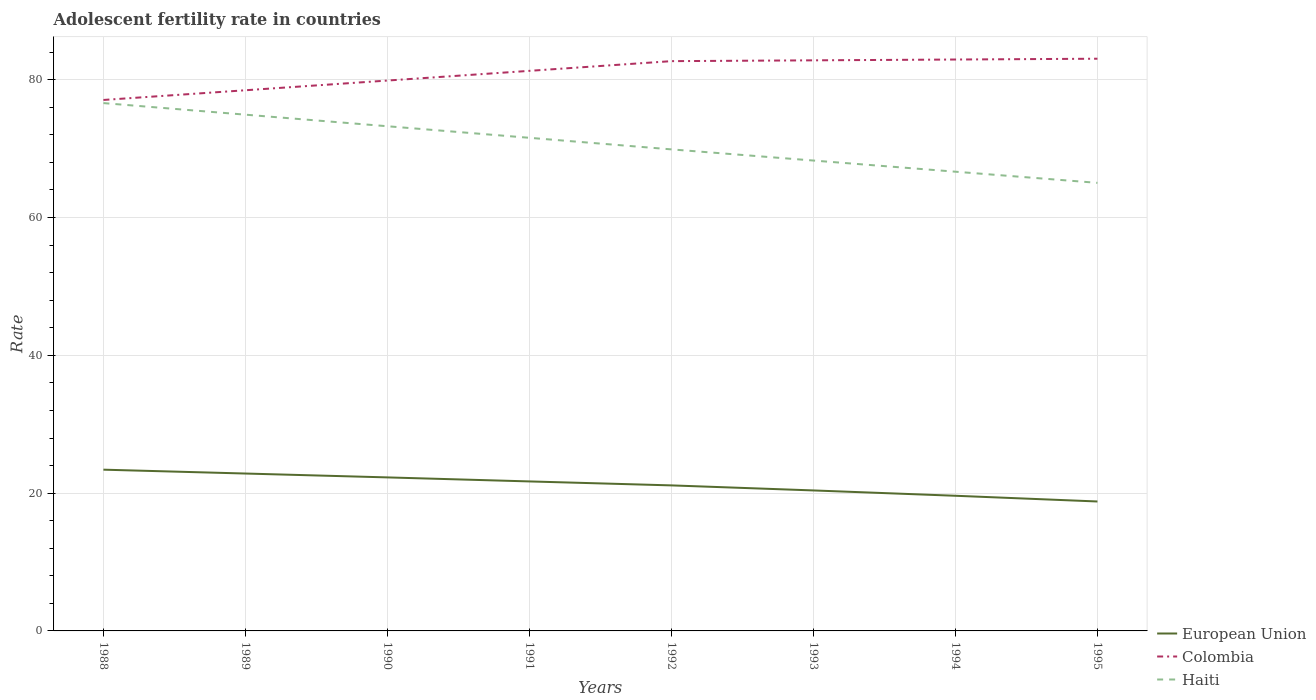How many different coloured lines are there?
Offer a very short reply. 3. Does the line corresponding to European Union intersect with the line corresponding to Haiti?
Keep it short and to the point. No. Is the number of lines equal to the number of legend labels?
Your answer should be compact. Yes. Across all years, what is the maximum adolescent fertility rate in European Union?
Your response must be concise. 18.79. In which year was the adolescent fertility rate in Haiti maximum?
Your response must be concise. 1995. What is the total adolescent fertility rate in European Union in the graph?
Make the answer very short. 3.02. What is the difference between the highest and the second highest adolescent fertility rate in European Union?
Provide a succinct answer. 4.62. How many lines are there?
Ensure brevity in your answer.  3. How many years are there in the graph?
Keep it short and to the point. 8. Are the values on the major ticks of Y-axis written in scientific E-notation?
Ensure brevity in your answer.  No. Does the graph contain any zero values?
Provide a succinct answer. No. Where does the legend appear in the graph?
Your answer should be very brief. Bottom right. How are the legend labels stacked?
Offer a very short reply. Vertical. What is the title of the graph?
Ensure brevity in your answer.  Adolescent fertility rate in countries. Does "Guam" appear as one of the legend labels in the graph?
Provide a succinct answer. No. What is the label or title of the Y-axis?
Your answer should be very brief. Rate. What is the Rate of European Union in 1988?
Your answer should be compact. 23.41. What is the Rate in Colombia in 1988?
Offer a terse response. 77.07. What is the Rate in Haiti in 1988?
Offer a terse response. 76.61. What is the Rate of European Union in 1989?
Keep it short and to the point. 22.84. What is the Rate in Colombia in 1989?
Ensure brevity in your answer.  78.48. What is the Rate in Haiti in 1989?
Provide a succinct answer. 74.93. What is the Rate of European Union in 1990?
Keep it short and to the point. 22.28. What is the Rate of Colombia in 1990?
Offer a terse response. 79.88. What is the Rate in Haiti in 1990?
Provide a succinct answer. 73.25. What is the Rate of European Union in 1991?
Your answer should be compact. 21.7. What is the Rate in Colombia in 1991?
Provide a short and direct response. 81.29. What is the Rate of Haiti in 1991?
Offer a very short reply. 71.57. What is the Rate of European Union in 1992?
Ensure brevity in your answer.  21.12. What is the Rate in Colombia in 1992?
Keep it short and to the point. 82.7. What is the Rate of Haiti in 1992?
Provide a short and direct response. 69.89. What is the Rate of European Union in 1993?
Provide a short and direct response. 20.39. What is the Rate in Colombia in 1993?
Your response must be concise. 82.82. What is the Rate in Haiti in 1993?
Your answer should be very brief. 68.27. What is the Rate of European Union in 1994?
Your answer should be very brief. 19.62. What is the Rate in Colombia in 1994?
Your answer should be compact. 82.94. What is the Rate of Haiti in 1994?
Your answer should be compact. 66.65. What is the Rate of European Union in 1995?
Offer a very short reply. 18.79. What is the Rate in Colombia in 1995?
Your response must be concise. 83.05. What is the Rate of Haiti in 1995?
Provide a short and direct response. 65.04. Across all years, what is the maximum Rate in European Union?
Provide a short and direct response. 23.41. Across all years, what is the maximum Rate in Colombia?
Provide a succinct answer. 83.05. Across all years, what is the maximum Rate in Haiti?
Ensure brevity in your answer.  76.61. Across all years, what is the minimum Rate in European Union?
Provide a short and direct response. 18.79. Across all years, what is the minimum Rate of Colombia?
Ensure brevity in your answer.  77.07. Across all years, what is the minimum Rate in Haiti?
Your answer should be compact. 65.04. What is the total Rate of European Union in the graph?
Your answer should be very brief. 170.15. What is the total Rate of Colombia in the graph?
Provide a succinct answer. 648.23. What is the total Rate of Haiti in the graph?
Offer a very short reply. 566.23. What is the difference between the Rate of European Union in 1988 and that in 1989?
Provide a short and direct response. 0.56. What is the difference between the Rate in Colombia in 1988 and that in 1989?
Provide a succinct answer. -1.41. What is the difference between the Rate in Haiti in 1988 and that in 1989?
Keep it short and to the point. 1.68. What is the difference between the Rate in European Union in 1988 and that in 1990?
Your answer should be very brief. 1.12. What is the difference between the Rate in Colombia in 1988 and that in 1990?
Your answer should be very brief. -2.82. What is the difference between the Rate of Haiti in 1988 and that in 1990?
Ensure brevity in your answer.  3.36. What is the difference between the Rate of European Union in 1988 and that in 1991?
Provide a succinct answer. 1.71. What is the difference between the Rate in Colombia in 1988 and that in 1991?
Your answer should be compact. -4.23. What is the difference between the Rate in Haiti in 1988 and that in 1991?
Provide a short and direct response. 5.04. What is the difference between the Rate in European Union in 1988 and that in 1992?
Give a very brief answer. 2.28. What is the difference between the Rate of Colombia in 1988 and that in 1992?
Your answer should be very brief. -5.63. What is the difference between the Rate in Haiti in 1988 and that in 1992?
Your answer should be compact. 6.72. What is the difference between the Rate of European Union in 1988 and that in 1993?
Your response must be concise. 3.02. What is the difference between the Rate of Colombia in 1988 and that in 1993?
Your answer should be very brief. -5.75. What is the difference between the Rate in Haiti in 1988 and that in 1993?
Give a very brief answer. 8.34. What is the difference between the Rate of European Union in 1988 and that in 1994?
Your response must be concise. 3.79. What is the difference between the Rate of Colombia in 1988 and that in 1994?
Your answer should be very brief. -5.87. What is the difference between the Rate of Haiti in 1988 and that in 1994?
Offer a very short reply. 9.96. What is the difference between the Rate of European Union in 1988 and that in 1995?
Your answer should be very brief. 4.62. What is the difference between the Rate in Colombia in 1988 and that in 1995?
Offer a very short reply. -5.99. What is the difference between the Rate of Haiti in 1988 and that in 1995?
Offer a terse response. 11.58. What is the difference between the Rate in European Union in 1989 and that in 1990?
Offer a terse response. 0.56. What is the difference between the Rate of Colombia in 1989 and that in 1990?
Keep it short and to the point. -1.41. What is the difference between the Rate of Haiti in 1989 and that in 1990?
Provide a succinct answer. 1.68. What is the difference between the Rate of European Union in 1989 and that in 1991?
Give a very brief answer. 1.15. What is the difference between the Rate of Colombia in 1989 and that in 1991?
Offer a very short reply. -2.82. What is the difference between the Rate in Haiti in 1989 and that in 1991?
Keep it short and to the point. 3.36. What is the difference between the Rate of European Union in 1989 and that in 1992?
Make the answer very short. 1.72. What is the difference between the Rate of Colombia in 1989 and that in 1992?
Keep it short and to the point. -4.23. What is the difference between the Rate in Haiti in 1989 and that in 1992?
Offer a terse response. 5.04. What is the difference between the Rate in European Union in 1989 and that in 1993?
Give a very brief answer. 2.45. What is the difference between the Rate of Colombia in 1989 and that in 1993?
Provide a succinct answer. -4.34. What is the difference between the Rate of Haiti in 1989 and that in 1993?
Your answer should be very brief. 6.66. What is the difference between the Rate of European Union in 1989 and that in 1994?
Your response must be concise. 3.23. What is the difference between the Rate of Colombia in 1989 and that in 1994?
Your answer should be compact. -4.46. What is the difference between the Rate in Haiti in 1989 and that in 1994?
Give a very brief answer. 8.28. What is the difference between the Rate of European Union in 1989 and that in 1995?
Offer a terse response. 4.06. What is the difference between the Rate in Colombia in 1989 and that in 1995?
Ensure brevity in your answer.  -4.58. What is the difference between the Rate in Haiti in 1989 and that in 1995?
Your response must be concise. 9.9. What is the difference between the Rate of European Union in 1990 and that in 1991?
Keep it short and to the point. 0.58. What is the difference between the Rate in Colombia in 1990 and that in 1991?
Your response must be concise. -1.41. What is the difference between the Rate of Haiti in 1990 and that in 1991?
Your answer should be very brief. 1.68. What is the difference between the Rate of European Union in 1990 and that in 1992?
Make the answer very short. 1.16. What is the difference between the Rate of Colombia in 1990 and that in 1992?
Keep it short and to the point. -2.82. What is the difference between the Rate of Haiti in 1990 and that in 1992?
Offer a terse response. 3.36. What is the difference between the Rate in European Union in 1990 and that in 1993?
Offer a very short reply. 1.89. What is the difference between the Rate of Colombia in 1990 and that in 1993?
Your response must be concise. -2.93. What is the difference between the Rate of Haiti in 1990 and that in 1993?
Provide a short and direct response. 4.98. What is the difference between the Rate of European Union in 1990 and that in 1994?
Ensure brevity in your answer.  2.67. What is the difference between the Rate in Colombia in 1990 and that in 1994?
Give a very brief answer. -3.05. What is the difference between the Rate in Haiti in 1990 and that in 1994?
Your response must be concise. 6.6. What is the difference between the Rate of European Union in 1990 and that in 1995?
Offer a very short reply. 3.5. What is the difference between the Rate in Colombia in 1990 and that in 1995?
Offer a terse response. -3.17. What is the difference between the Rate in Haiti in 1990 and that in 1995?
Your answer should be very brief. 8.22. What is the difference between the Rate in European Union in 1991 and that in 1992?
Provide a short and direct response. 0.58. What is the difference between the Rate of Colombia in 1991 and that in 1992?
Your answer should be very brief. -1.41. What is the difference between the Rate in Haiti in 1991 and that in 1992?
Your response must be concise. 1.68. What is the difference between the Rate of European Union in 1991 and that in 1993?
Keep it short and to the point. 1.31. What is the difference between the Rate of Colombia in 1991 and that in 1993?
Offer a terse response. -1.53. What is the difference between the Rate in Haiti in 1991 and that in 1993?
Keep it short and to the point. 3.3. What is the difference between the Rate in European Union in 1991 and that in 1994?
Your answer should be very brief. 2.08. What is the difference between the Rate of Colombia in 1991 and that in 1994?
Your answer should be very brief. -1.64. What is the difference between the Rate of Haiti in 1991 and that in 1994?
Ensure brevity in your answer.  4.92. What is the difference between the Rate in European Union in 1991 and that in 1995?
Make the answer very short. 2.91. What is the difference between the Rate in Colombia in 1991 and that in 1995?
Provide a succinct answer. -1.76. What is the difference between the Rate in Haiti in 1991 and that in 1995?
Keep it short and to the point. 6.54. What is the difference between the Rate in European Union in 1992 and that in 1993?
Your answer should be compact. 0.73. What is the difference between the Rate of Colombia in 1992 and that in 1993?
Keep it short and to the point. -0.12. What is the difference between the Rate of Haiti in 1992 and that in 1993?
Your answer should be compact. 1.62. What is the difference between the Rate of European Union in 1992 and that in 1994?
Provide a short and direct response. 1.51. What is the difference between the Rate of Colombia in 1992 and that in 1994?
Provide a short and direct response. -0.23. What is the difference between the Rate in Haiti in 1992 and that in 1994?
Offer a very short reply. 3.24. What is the difference between the Rate in European Union in 1992 and that in 1995?
Give a very brief answer. 2.34. What is the difference between the Rate of Colombia in 1992 and that in 1995?
Offer a very short reply. -0.35. What is the difference between the Rate of Haiti in 1992 and that in 1995?
Provide a short and direct response. 4.86. What is the difference between the Rate of European Union in 1993 and that in 1994?
Your answer should be very brief. 0.77. What is the difference between the Rate in Colombia in 1993 and that in 1994?
Give a very brief answer. -0.12. What is the difference between the Rate in Haiti in 1993 and that in 1994?
Your answer should be compact. 1.62. What is the difference between the Rate in European Union in 1993 and that in 1995?
Your answer should be very brief. 1.6. What is the difference between the Rate in Colombia in 1993 and that in 1995?
Ensure brevity in your answer.  -0.23. What is the difference between the Rate in Haiti in 1993 and that in 1995?
Ensure brevity in your answer.  3.24. What is the difference between the Rate of European Union in 1994 and that in 1995?
Ensure brevity in your answer.  0.83. What is the difference between the Rate of Colombia in 1994 and that in 1995?
Ensure brevity in your answer.  -0.12. What is the difference between the Rate of Haiti in 1994 and that in 1995?
Give a very brief answer. 1.62. What is the difference between the Rate of European Union in 1988 and the Rate of Colombia in 1989?
Make the answer very short. -55.07. What is the difference between the Rate of European Union in 1988 and the Rate of Haiti in 1989?
Make the answer very short. -51.53. What is the difference between the Rate of Colombia in 1988 and the Rate of Haiti in 1989?
Keep it short and to the point. 2.13. What is the difference between the Rate of European Union in 1988 and the Rate of Colombia in 1990?
Provide a succinct answer. -56.48. What is the difference between the Rate in European Union in 1988 and the Rate in Haiti in 1990?
Make the answer very short. -49.85. What is the difference between the Rate in Colombia in 1988 and the Rate in Haiti in 1990?
Your answer should be very brief. 3.81. What is the difference between the Rate in European Union in 1988 and the Rate in Colombia in 1991?
Offer a terse response. -57.89. What is the difference between the Rate of European Union in 1988 and the Rate of Haiti in 1991?
Keep it short and to the point. -48.17. What is the difference between the Rate of Colombia in 1988 and the Rate of Haiti in 1991?
Ensure brevity in your answer.  5.49. What is the difference between the Rate of European Union in 1988 and the Rate of Colombia in 1992?
Offer a very short reply. -59.3. What is the difference between the Rate in European Union in 1988 and the Rate in Haiti in 1992?
Your response must be concise. -46.49. What is the difference between the Rate in Colombia in 1988 and the Rate in Haiti in 1992?
Provide a succinct answer. 7.17. What is the difference between the Rate in European Union in 1988 and the Rate in Colombia in 1993?
Ensure brevity in your answer.  -59.41. What is the difference between the Rate of European Union in 1988 and the Rate of Haiti in 1993?
Ensure brevity in your answer.  -44.87. What is the difference between the Rate in Colombia in 1988 and the Rate in Haiti in 1993?
Give a very brief answer. 8.79. What is the difference between the Rate of European Union in 1988 and the Rate of Colombia in 1994?
Your answer should be compact. -59.53. What is the difference between the Rate of European Union in 1988 and the Rate of Haiti in 1994?
Your answer should be very brief. -43.25. What is the difference between the Rate of Colombia in 1988 and the Rate of Haiti in 1994?
Provide a succinct answer. 10.41. What is the difference between the Rate in European Union in 1988 and the Rate in Colombia in 1995?
Offer a very short reply. -59.65. What is the difference between the Rate of European Union in 1988 and the Rate of Haiti in 1995?
Make the answer very short. -41.63. What is the difference between the Rate in Colombia in 1988 and the Rate in Haiti in 1995?
Your response must be concise. 12.03. What is the difference between the Rate in European Union in 1989 and the Rate in Colombia in 1990?
Your answer should be very brief. -57.04. What is the difference between the Rate of European Union in 1989 and the Rate of Haiti in 1990?
Make the answer very short. -50.41. What is the difference between the Rate of Colombia in 1989 and the Rate of Haiti in 1990?
Keep it short and to the point. 5.22. What is the difference between the Rate in European Union in 1989 and the Rate in Colombia in 1991?
Provide a short and direct response. -58.45. What is the difference between the Rate in European Union in 1989 and the Rate in Haiti in 1991?
Give a very brief answer. -48.73. What is the difference between the Rate in Colombia in 1989 and the Rate in Haiti in 1991?
Provide a short and direct response. 6.9. What is the difference between the Rate in European Union in 1989 and the Rate in Colombia in 1992?
Ensure brevity in your answer.  -59.86. What is the difference between the Rate of European Union in 1989 and the Rate of Haiti in 1992?
Provide a short and direct response. -47.05. What is the difference between the Rate of Colombia in 1989 and the Rate of Haiti in 1992?
Ensure brevity in your answer.  8.58. What is the difference between the Rate of European Union in 1989 and the Rate of Colombia in 1993?
Give a very brief answer. -59.97. What is the difference between the Rate of European Union in 1989 and the Rate of Haiti in 1993?
Provide a succinct answer. -45.43. What is the difference between the Rate in Colombia in 1989 and the Rate in Haiti in 1993?
Offer a very short reply. 10.2. What is the difference between the Rate of European Union in 1989 and the Rate of Colombia in 1994?
Provide a short and direct response. -60.09. What is the difference between the Rate of European Union in 1989 and the Rate of Haiti in 1994?
Give a very brief answer. -43.81. What is the difference between the Rate in Colombia in 1989 and the Rate in Haiti in 1994?
Provide a short and direct response. 11.82. What is the difference between the Rate in European Union in 1989 and the Rate in Colombia in 1995?
Keep it short and to the point. -60.21. What is the difference between the Rate of European Union in 1989 and the Rate of Haiti in 1995?
Ensure brevity in your answer.  -42.19. What is the difference between the Rate of Colombia in 1989 and the Rate of Haiti in 1995?
Give a very brief answer. 13.44. What is the difference between the Rate of European Union in 1990 and the Rate of Colombia in 1991?
Offer a very short reply. -59.01. What is the difference between the Rate in European Union in 1990 and the Rate in Haiti in 1991?
Your answer should be very brief. -49.29. What is the difference between the Rate of Colombia in 1990 and the Rate of Haiti in 1991?
Offer a very short reply. 8.31. What is the difference between the Rate in European Union in 1990 and the Rate in Colombia in 1992?
Your answer should be very brief. -60.42. What is the difference between the Rate in European Union in 1990 and the Rate in Haiti in 1992?
Make the answer very short. -47.61. What is the difference between the Rate in Colombia in 1990 and the Rate in Haiti in 1992?
Offer a terse response. 9.99. What is the difference between the Rate of European Union in 1990 and the Rate of Colombia in 1993?
Ensure brevity in your answer.  -60.54. What is the difference between the Rate in European Union in 1990 and the Rate in Haiti in 1993?
Provide a short and direct response. -45.99. What is the difference between the Rate in Colombia in 1990 and the Rate in Haiti in 1993?
Offer a very short reply. 11.61. What is the difference between the Rate in European Union in 1990 and the Rate in Colombia in 1994?
Your answer should be compact. -60.65. What is the difference between the Rate in European Union in 1990 and the Rate in Haiti in 1994?
Provide a succinct answer. -44.37. What is the difference between the Rate in Colombia in 1990 and the Rate in Haiti in 1994?
Offer a terse response. 13.23. What is the difference between the Rate in European Union in 1990 and the Rate in Colombia in 1995?
Offer a very short reply. -60.77. What is the difference between the Rate of European Union in 1990 and the Rate of Haiti in 1995?
Ensure brevity in your answer.  -42.75. What is the difference between the Rate of Colombia in 1990 and the Rate of Haiti in 1995?
Make the answer very short. 14.85. What is the difference between the Rate of European Union in 1991 and the Rate of Colombia in 1992?
Keep it short and to the point. -61. What is the difference between the Rate of European Union in 1991 and the Rate of Haiti in 1992?
Give a very brief answer. -48.2. What is the difference between the Rate of Colombia in 1991 and the Rate of Haiti in 1992?
Ensure brevity in your answer.  11.4. What is the difference between the Rate in European Union in 1991 and the Rate in Colombia in 1993?
Make the answer very short. -61.12. What is the difference between the Rate in European Union in 1991 and the Rate in Haiti in 1993?
Your answer should be compact. -46.58. What is the difference between the Rate of Colombia in 1991 and the Rate of Haiti in 1993?
Your answer should be very brief. 13.02. What is the difference between the Rate of European Union in 1991 and the Rate of Colombia in 1994?
Keep it short and to the point. -61.24. What is the difference between the Rate of European Union in 1991 and the Rate of Haiti in 1994?
Provide a succinct answer. -44.96. What is the difference between the Rate in Colombia in 1991 and the Rate in Haiti in 1994?
Your response must be concise. 14.64. What is the difference between the Rate in European Union in 1991 and the Rate in Colombia in 1995?
Your response must be concise. -61.36. What is the difference between the Rate of European Union in 1991 and the Rate of Haiti in 1995?
Make the answer very short. -43.34. What is the difference between the Rate of Colombia in 1991 and the Rate of Haiti in 1995?
Provide a short and direct response. 16.26. What is the difference between the Rate of European Union in 1992 and the Rate of Colombia in 1993?
Provide a short and direct response. -61.7. What is the difference between the Rate of European Union in 1992 and the Rate of Haiti in 1993?
Provide a succinct answer. -47.15. What is the difference between the Rate in Colombia in 1992 and the Rate in Haiti in 1993?
Your answer should be very brief. 14.43. What is the difference between the Rate in European Union in 1992 and the Rate in Colombia in 1994?
Your answer should be very brief. -61.81. What is the difference between the Rate of European Union in 1992 and the Rate of Haiti in 1994?
Offer a very short reply. -45.53. What is the difference between the Rate in Colombia in 1992 and the Rate in Haiti in 1994?
Ensure brevity in your answer.  16.05. What is the difference between the Rate of European Union in 1992 and the Rate of Colombia in 1995?
Offer a terse response. -61.93. What is the difference between the Rate in European Union in 1992 and the Rate in Haiti in 1995?
Provide a succinct answer. -43.91. What is the difference between the Rate of Colombia in 1992 and the Rate of Haiti in 1995?
Offer a terse response. 17.67. What is the difference between the Rate in European Union in 1993 and the Rate in Colombia in 1994?
Keep it short and to the point. -62.55. What is the difference between the Rate in European Union in 1993 and the Rate in Haiti in 1994?
Your answer should be very brief. -46.26. What is the difference between the Rate of Colombia in 1993 and the Rate of Haiti in 1994?
Offer a very short reply. 16.16. What is the difference between the Rate in European Union in 1993 and the Rate in Colombia in 1995?
Give a very brief answer. -62.66. What is the difference between the Rate in European Union in 1993 and the Rate in Haiti in 1995?
Provide a short and direct response. -44.64. What is the difference between the Rate of Colombia in 1993 and the Rate of Haiti in 1995?
Your response must be concise. 17.78. What is the difference between the Rate in European Union in 1994 and the Rate in Colombia in 1995?
Provide a succinct answer. -63.44. What is the difference between the Rate of European Union in 1994 and the Rate of Haiti in 1995?
Provide a short and direct response. -45.42. What is the difference between the Rate in Colombia in 1994 and the Rate in Haiti in 1995?
Provide a succinct answer. 17.9. What is the average Rate of European Union per year?
Your answer should be compact. 21.27. What is the average Rate in Colombia per year?
Your answer should be compact. 81.03. What is the average Rate of Haiti per year?
Provide a short and direct response. 70.78. In the year 1988, what is the difference between the Rate in European Union and Rate in Colombia?
Your answer should be compact. -53.66. In the year 1988, what is the difference between the Rate of European Union and Rate of Haiti?
Provide a succinct answer. -53.21. In the year 1988, what is the difference between the Rate in Colombia and Rate in Haiti?
Your answer should be compact. 0.46. In the year 1989, what is the difference between the Rate in European Union and Rate in Colombia?
Ensure brevity in your answer.  -55.63. In the year 1989, what is the difference between the Rate of European Union and Rate of Haiti?
Make the answer very short. -52.09. In the year 1989, what is the difference between the Rate in Colombia and Rate in Haiti?
Provide a succinct answer. 3.54. In the year 1990, what is the difference between the Rate of European Union and Rate of Colombia?
Offer a very short reply. -57.6. In the year 1990, what is the difference between the Rate of European Union and Rate of Haiti?
Your answer should be very brief. -50.97. In the year 1990, what is the difference between the Rate of Colombia and Rate of Haiti?
Your answer should be very brief. 6.63. In the year 1991, what is the difference between the Rate in European Union and Rate in Colombia?
Provide a short and direct response. -59.59. In the year 1991, what is the difference between the Rate in European Union and Rate in Haiti?
Make the answer very short. -49.87. In the year 1991, what is the difference between the Rate of Colombia and Rate of Haiti?
Your answer should be very brief. 9.72. In the year 1992, what is the difference between the Rate in European Union and Rate in Colombia?
Provide a succinct answer. -61.58. In the year 1992, what is the difference between the Rate in European Union and Rate in Haiti?
Offer a terse response. -48.77. In the year 1992, what is the difference between the Rate of Colombia and Rate of Haiti?
Your answer should be very brief. 12.81. In the year 1993, what is the difference between the Rate of European Union and Rate of Colombia?
Provide a short and direct response. -62.43. In the year 1993, what is the difference between the Rate of European Union and Rate of Haiti?
Give a very brief answer. -47.88. In the year 1993, what is the difference between the Rate of Colombia and Rate of Haiti?
Your response must be concise. 14.54. In the year 1994, what is the difference between the Rate of European Union and Rate of Colombia?
Make the answer very short. -63.32. In the year 1994, what is the difference between the Rate of European Union and Rate of Haiti?
Your answer should be very brief. -47.04. In the year 1994, what is the difference between the Rate in Colombia and Rate in Haiti?
Offer a terse response. 16.28. In the year 1995, what is the difference between the Rate in European Union and Rate in Colombia?
Make the answer very short. -64.27. In the year 1995, what is the difference between the Rate in European Union and Rate in Haiti?
Your answer should be very brief. -46.25. In the year 1995, what is the difference between the Rate in Colombia and Rate in Haiti?
Your response must be concise. 18.02. What is the ratio of the Rate in European Union in 1988 to that in 1989?
Keep it short and to the point. 1.02. What is the ratio of the Rate of Colombia in 1988 to that in 1989?
Ensure brevity in your answer.  0.98. What is the ratio of the Rate in Haiti in 1988 to that in 1989?
Offer a very short reply. 1.02. What is the ratio of the Rate of European Union in 1988 to that in 1990?
Provide a short and direct response. 1.05. What is the ratio of the Rate in Colombia in 1988 to that in 1990?
Your answer should be very brief. 0.96. What is the ratio of the Rate of Haiti in 1988 to that in 1990?
Your answer should be very brief. 1.05. What is the ratio of the Rate of European Union in 1988 to that in 1991?
Make the answer very short. 1.08. What is the ratio of the Rate in Colombia in 1988 to that in 1991?
Offer a very short reply. 0.95. What is the ratio of the Rate in Haiti in 1988 to that in 1991?
Offer a terse response. 1.07. What is the ratio of the Rate of European Union in 1988 to that in 1992?
Ensure brevity in your answer.  1.11. What is the ratio of the Rate in Colombia in 1988 to that in 1992?
Give a very brief answer. 0.93. What is the ratio of the Rate of Haiti in 1988 to that in 1992?
Keep it short and to the point. 1.1. What is the ratio of the Rate in European Union in 1988 to that in 1993?
Your response must be concise. 1.15. What is the ratio of the Rate of Colombia in 1988 to that in 1993?
Keep it short and to the point. 0.93. What is the ratio of the Rate of Haiti in 1988 to that in 1993?
Your answer should be compact. 1.12. What is the ratio of the Rate in European Union in 1988 to that in 1994?
Your answer should be compact. 1.19. What is the ratio of the Rate of Colombia in 1988 to that in 1994?
Your answer should be compact. 0.93. What is the ratio of the Rate in Haiti in 1988 to that in 1994?
Ensure brevity in your answer.  1.15. What is the ratio of the Rate in European Union in 1988 to that in 1995?
Ensure brevity in your answer.  1.25. What is the ratio of the Rate in Colombia in 1988 to that in 1995?
Your answer should be compact. 0.93. What is the ratio of the Rate of Haiti in 1988 to that in 1995?
Ensure brevity in your answer.  1.18. What is the ratio of the Rate of European Union in 1989 to that in 1990?
Keep it short and to the point. 1.03. What is the ratio of the Rate of Colombia in 1989 to that in 1990?
Ensure brevity in your answer.  0.98. What is the ratio of the Rate of Haiti in 1989 to that in 1990?
Offer a terse response. 1.02. What is the ratio of the Rate in European Union in 1989 to that in 1991?
Your answer should be compact. 1.05. What is the ratio of the Rate of Colombia in 1989 to that in 1991?
Your answer should be compact. 0.97. What is the ratio of the Rate in Haiti in 1989 to that in 1991?
Make the answer very short. 1.05. What is the ratio of the Rate in European Union in 1989 to that in 1992?
Your response must be concise. 1.08. What is the ratio of the Rate in Colombia in 1989 to that in 1992?
Offer a terse response. 0.95. What is the ratio of the Rate of Haiti in 1989 to that in 1992?
Your response must be concise. 1.07. What is the ratio of the Rate in European Union in 1989 to that in 1993?
Keep it short and to the point. 1.12. What is the ratio of the Rate of Colombia in 1989 to that in 1993?
Provide a short and direct response. 0.95. What is the ratio of the Rate in Haiti in 1989 to that in 1993?
Make the answer very short. 1.1. What is the ratio of the Rate of European Union in 1989 to that in 1994?
Provide a succinct answer. 1.16. What is the ratio of the Rate of Colombia in 1989 to that in 1994?
Offer a very short reply. 0.95. What is the ratio of the Rate in Haiti in 1989 to that in 1994?
Keep it short and to the point. 1.12. What is the ratio of the Rate of European Union in 1989 to that in 1995?
Provide a short and direct response. 1.22. What is the ratio of the Rate in Colombia in 1989 to that in 1995?
Keep it short and to the point. 0.94. What is the ratio of the Rate in Haiti in 1989 to that in 1995?
Your answer should be compact. 1.15. What is the ratio of the Rate in European Union in 1990 to that in 1991?
Give a very brief answer. 1.03. What is the ratio of the Rate of Colombia in 1990 to that in 1991?
Give a very brief answer. 0.98. What is the ratio of the Rate of Haiti in 1990 to that in 1991?
Provide a succinct answer. 1.02. What is the ratio of the Rate of European Union in 1990 to that in 1992?
Your answer should be very brief. 1.05. What is the ratio of the Rate of Colombia in 1990 to that in 1992?
Your answer should be very brief. 0.97. What is the ratio of the Rate in Haiti in 1990 to that in 1992?
Your answer should be compact. 1.05. What is the ratio of the Rate in European Union in 1990 to that in 1993?
Keep it short and to the point. 1.09. What is the ratio of the Rate of Colombia in 1990 to that in 1993?
Your response must be concise. 0.96. What is the ratio of the Rate of Haiti in 1990 to that in 1993?
Your answer should be compact. 1.07. What is the ratio of the Rate in European Union in 1990 to that in 1994?
Provide a succinct answer. 1.14. What is the ratio of the Rate of Colombia in 1990 to that in 1994?
Your answer should be compact. 0.96. What is the ratio of the Rate of Haiti in 1990 to that in 1994?
Keep it short and to the point. 1.1. What is the ratio of the Rate of European Union in 1990 to that in 1995?
Offer a terse response. 1.19. What is the ratio of the Rate in Colombia in 1990 to that in 1995?
Your answer should be compact. 0.96. What is the ratio of the Rate of Haiti in 1990 to that in 1995?
Your response must be concise. 1.13. What is the ratio of the Rate of European Union in 1991 to that in 1992?
Provide a short and direct response. 1.03. What is the ratio of the Rate of European Union in 1991 to that in 1993?
Ensure brevity in your answer.  1.06. What is the ratio of the Rate in Colombia in 1991 to that in 1993?
Ensure brevity in your answer.  0.98. What is the ratio of the Rate of Haiti in 1991 to that in 1993?
Keep it short and to the point. 1.05. What is the ratio of the Rate in European Union in 1991 to that in 1994?
Provide a succinct answer. 1.11. What is the ratio of the Rate of Colombia in 1991 to that in 1994?
Your answer should be compact. 0.98. What is the ratio of the Rate of Haiti in 1991 to that in 1994?
Your response must be concise. 1.07. What is the ratio of the Rate in European Union in 1991 to that in 1995?
Your response must be concise. 1.16. What is the ratio of the Rate of Colombia in 1991 to that in 1995?
Keep it short and to the point. 0.98. What is the ratio of the Rate of Haiti in 1991 to that in 1995?
Provide a short and direct response. 1.1. What is the ratio of the Rate in European Union in 1992 to that in 1993?
Give a very brief answer. 1.04. What is the ratio of the Rate in Haiti in 1992 to that in 1993?
Your response must be concise. 1.02. What is the ratio of the Rate in European Union in 1992 to that in 1994?
Your response must be concise. 1.08. What is the ratio of the Rate in Colombia in 1992 to that in 1994?
Provide a short and direct response. 1. What is the ratio of the Rate of Haiti in 1992 to that in 1994?
Give a very brief answer. 1.05. What is the ratio of the Rate of European Union in 1992 to that in 1995?
Your answer should be very brief. 1.12. What is the ratio of the Rate in Colombia in 1992 to that in 1995?
Keep it short and to the point. 1. What is the ratio of the Rate of Haiti in 1992 to that in 1995?
Provide a short and direct response. 1.07. What is the ratio of the Rate in European Union in 1993 to that in 1994?
Provide a short and direct response. 1.04. What is the ratio of the Rate in Colombia in 1993 to that in 1994?
Your answer should be compact. 1. What is the ratio of the Rate of Haiti in 1993 to that in 1994?
Make the answer very short. 1.02. What is the ratio of the Rate in European Union in 1993 to that in 1995?
Offer a terse response. 1.09. What is the ratio of the Rate of Haiti in 1993 to that in 1995?
Your answer should be very brief. 1.05. What is the ratio of the Rate of European Union in 1994 to that in 1995?
Your answer should be compact. 1.04. What is the ratio of the Rate in Colombia in 1994 to that in 1995?
Give a very brief answer. 1. What is the ratio of the Rate of Haiti in 1994 to that in 1995?
Your response must be concise. 1.02. What is the difference between the highest and the second highest Rate in European Union?
Your answer should be very brief. 0.56. What is the difference between the highest and the second highest Rate of Colombia?
Make the answer very short. 0.12. What is the difference between the highest and the second highest Rate in Haiti?
Your answer should be compact. 1.68. What is the difference between the highest and the lowest Rate in European Union?
Keep it short and to the point. 4.62. What is the difference between the highest and the lowest Rate in Colombia?
Keep it short and to the point. 5.99. What is the difference between the highest and the lowest Rate in Haiti?
Keep it short and to the point. 11.58. 